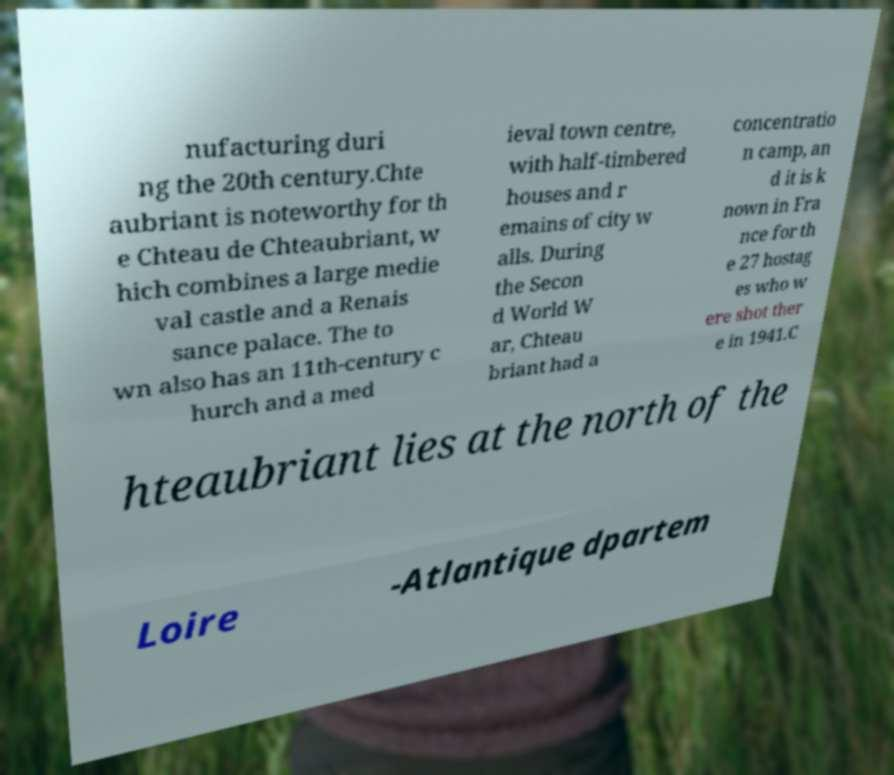I need the written content from this picture converted into text. Can you do that? nufacturing duri ng the 20th century.Chte aubriant is noteworthy for th e Chteau de Chteaubriant, w hich combines a large medie val castle and a Renais sance palace. The to wn also has an 11th-century c hurch and a med ieval town centre, with half-timbered houses and r emains of city w alls. During the Secon d World W ar, Chteau briant had a concentratio n camp, an d it is k nown in Fra nce for th e 27 hostag es who w ere shot ther e in 1941.C hteaubriant lies at the north of the Loire -Atlantique dpartem 